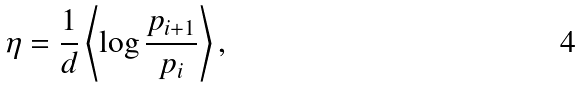<formula> <loc_0><loc_0><loc_500><loc_500>\eta = \frac { 1 } { d } \left \langle \log \frac { p _ { i + 1 } } { p _ { i } } \right \rangle ,</formula> 